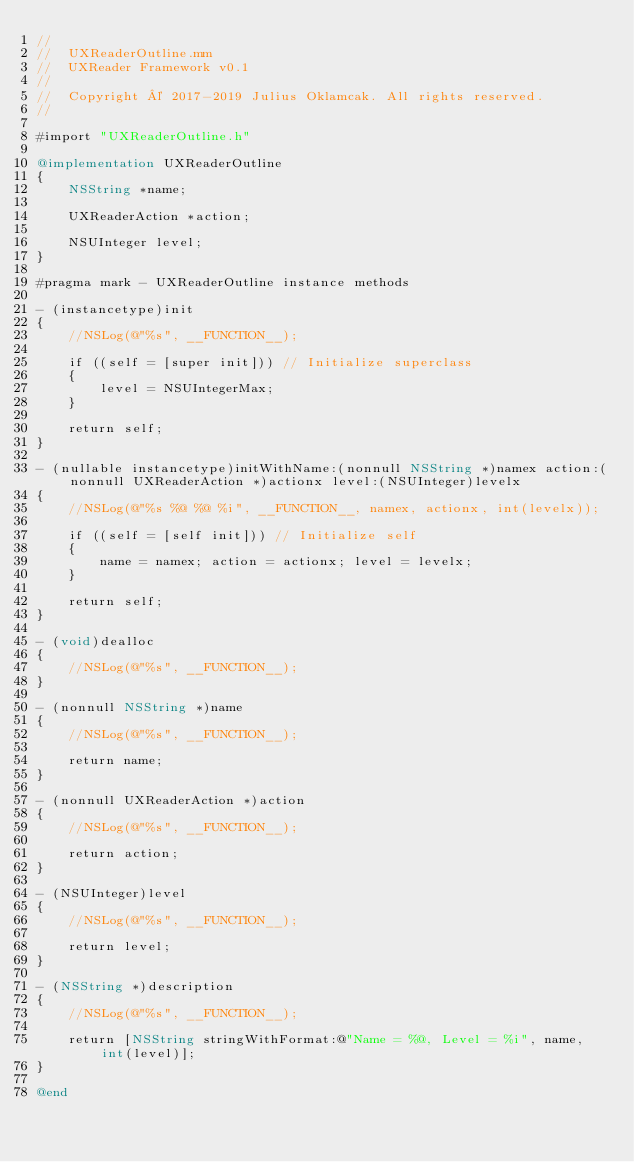<code> <loc_0><loc_0><loc_500><loc_500><_ObjectiveC_>//
//	UXReaderOutline.mm
//	UXReader Framework v0.1
//
//	Copyright © 2017-2019 Julius Oklamcak. All rights reserved.
//

#import "UXReaderOutline.h"

@implementation UXReaderOutline
{
	NSString *name;

	UXReaderAction *action;

	NSUInteger level;
}

#pragma mark - UXReaderOutline instance methods

- (instancetype)init
{
	//NSLog(@"%s", __FUNCTION__);

	if ((self = [super init])) // Initialize superclass
	{
		level = NSUIntegerMax;
	}

	return self;
}

- (nullable instancetype)initWithName:(nonnull NSString *)namex action:(nonnull UXReaderAction *)actionx level:(NSUInteger)levelx
{
	//NSLog(@"%s %@ %@ %i", __FUNCTION__, namex, actionx, int(levelx));

	if ((self = [self init])) // Initialize self
	{
		name = namex; action = actionx; level = levelx;
	}

	return self;
}

- (void)dealloc
{
	//NSLog(@"%s", __FUNCTION__);
}

- (nonnull NSString *)name
{
	//NSLog(@"%s", __FUNCTION__);

	return name;
}

- (nonnull UXReaderAction *)action
{
	//NSLog(@"%s", __FUNCTION__);

	return action;
}

- (NSUInteger)level
{
	//NSLog(@"%s", __FUNCTION__);

	return level;
}

- (NSString *)description
{
	//NSLog(@"%s", __FUNCTION__);

	return [NSString stringWithFormat:@"Name = %@, Level = %i", name, int(level)];
}

@end
</code> 